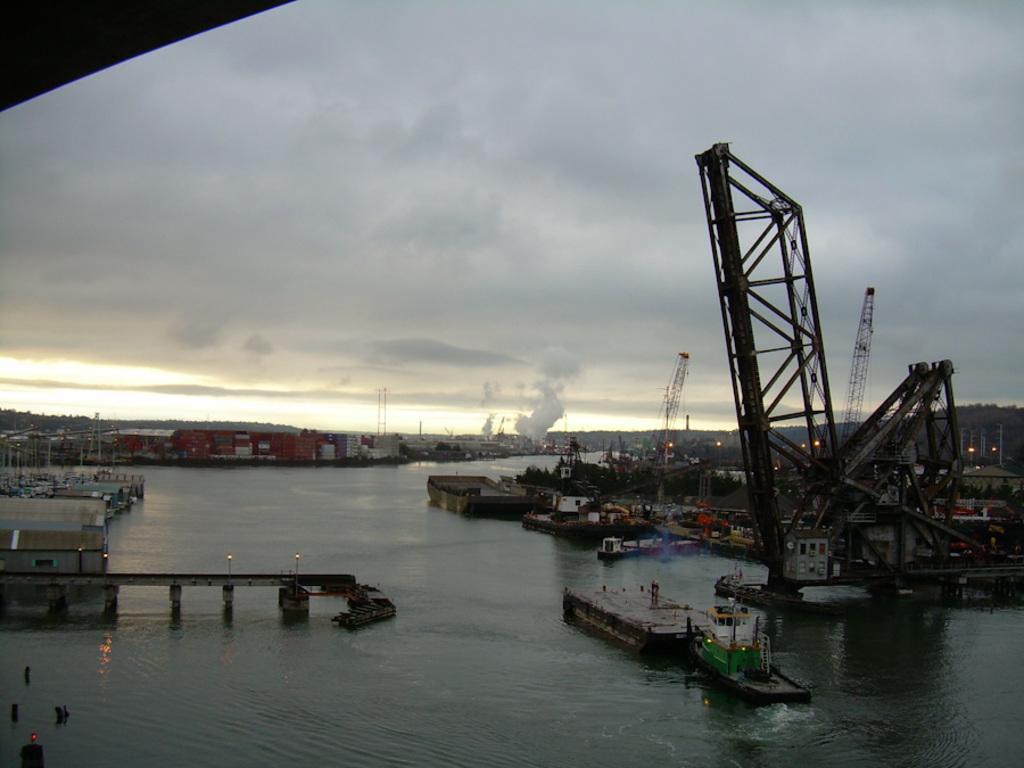Please provide a concise description of this image. In this image I can see the water, a bridge, few lights, few cranes and a boat on the surface of the water. In the background I can see few buildings, few poles, some smoke, few lights and the sky. 